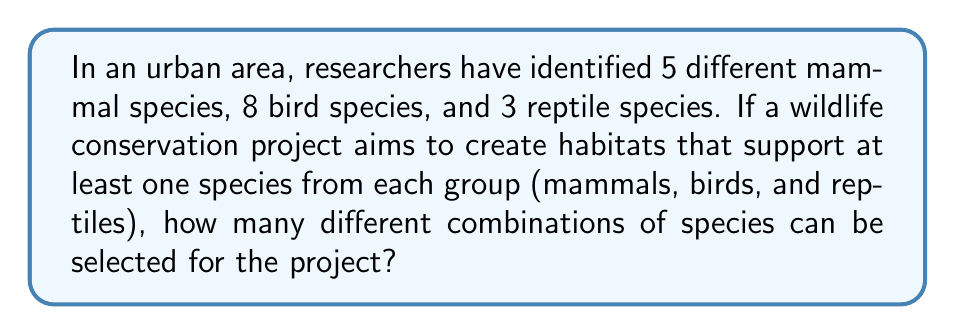Help me with this question. To solve this problem, we'll use the multiplication principle of counting. We need to select one species from each group, and the choices for each group are independent of each other.

1. For mammals: There are 5 choices.
2. For birds: There are 8 choices.
3. For reptiles: There are 3 choices.

The total number of combinations is the product of the number of choices for each group:

$$ \text{Total combinations} = 5 \times 8 \times 3 $$

Calculating:
$$ 5 \times 8 \times 3 = 40 \times 3 = 120 $$

Therefore, there are 120 different combinations of species that can be selected for the project.
Answer: 120 